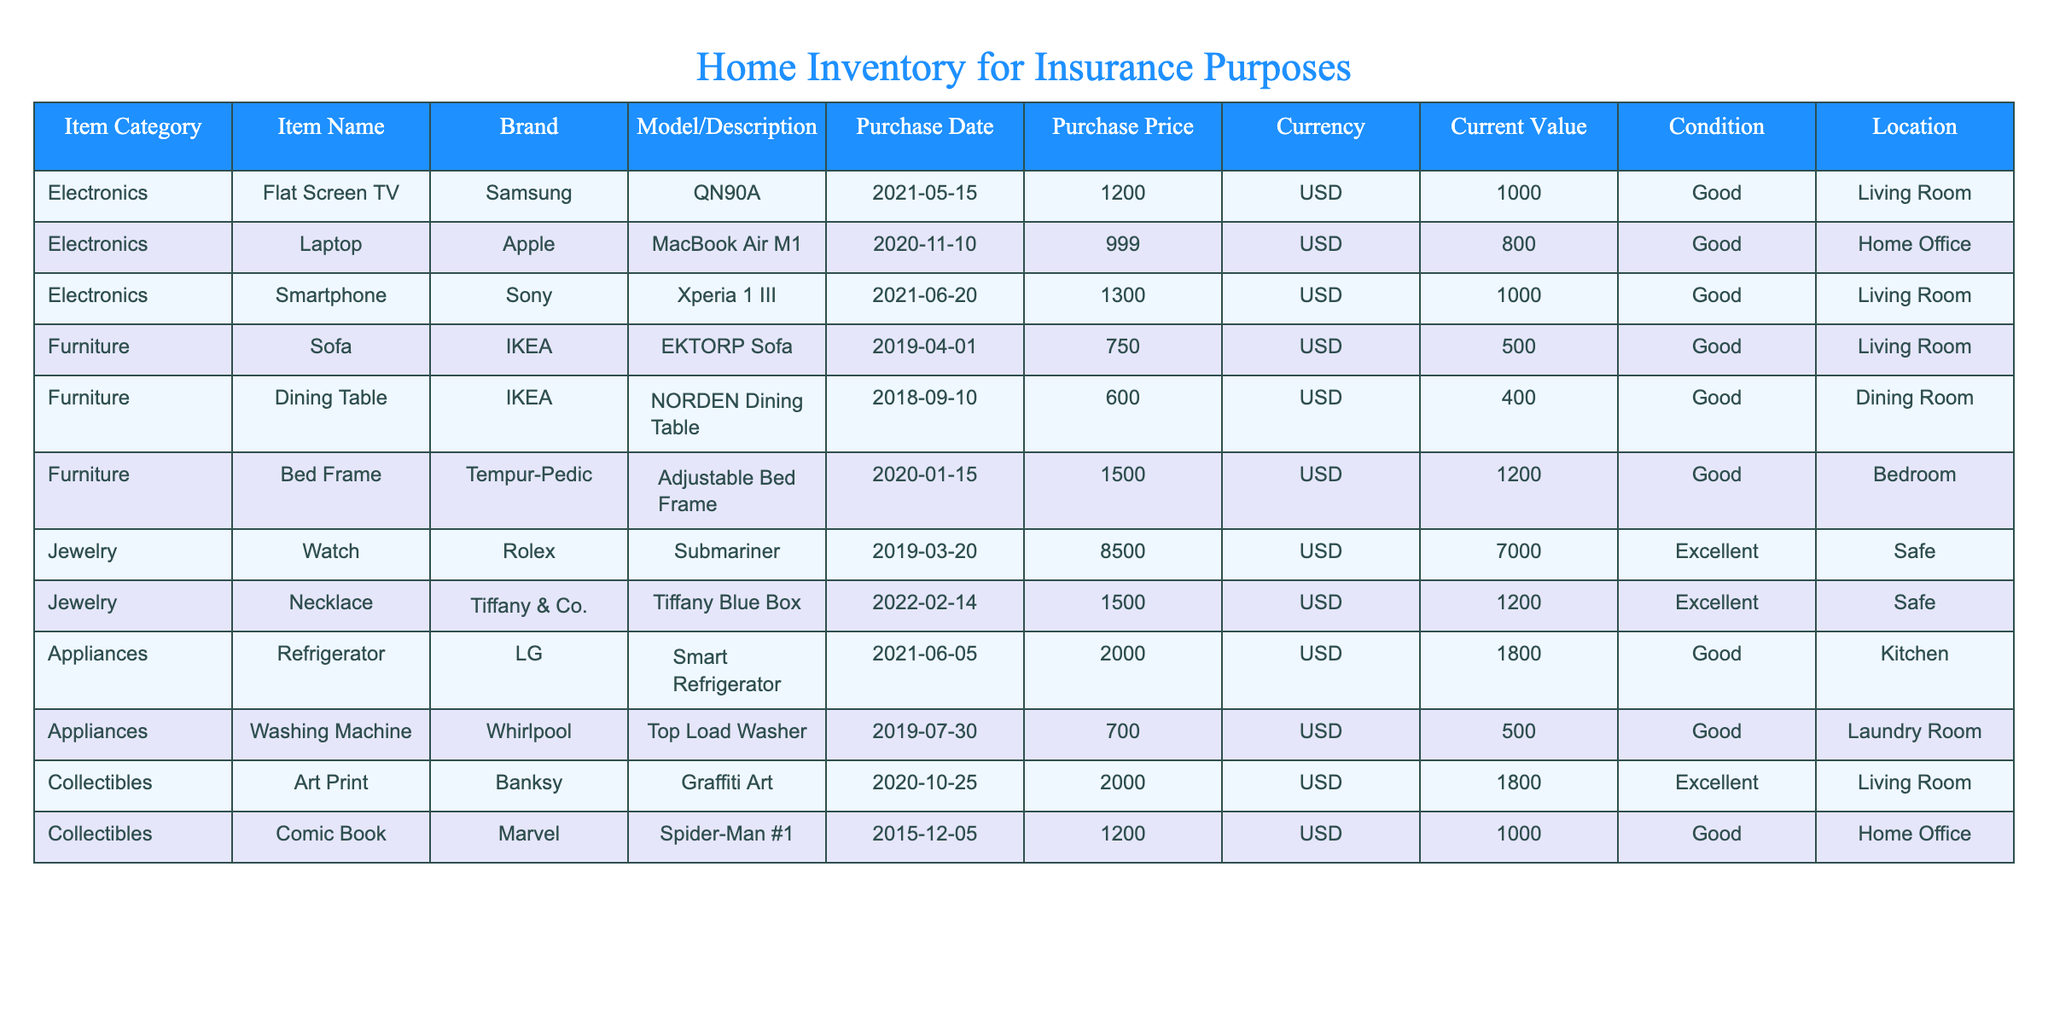What is the current value of the Flat Screen TV? The table lists the Flat Screen TV under the Electronics category and shows its current value. By checking the respective row, the current value is found to be 1000 USD.
Answer: 1000 USD What item has the highest purchase price? To find this, we compare the purchase prices of all items listed in the table. By scanning through the Purchase Price column, the highest value is identified as 8500 USD for the Rolex Watch.
Answer: 8500 USD How much is the total current value of all the items listed? We add the current values of all items: 1000 + 800 + 1000 + 500 + 400 + 1200 + 7000 + 1200 + 1800 + 500 + 1800 + 1000 = 19300 USD. Thus, the total current value is 19300 USD.
Answer: 19300 USD Is the Dining Table in good condition? By checking the condition of the Dining Table in the table, we see that its condition status is labeled as "Good". Therefore, it is indeed in good condition.
Answer: Yes Which category has the most expensive item, and what is that item's current value? We examine the current values in each category. The highest current value found is 7000 USD for the Rolex watch in the Jewelry category. Therefore, the category 'Jewelry' has the most expensive item.
Answer: Jewelry, 7000 USD What is the average purchase price of the appliances? The purchase prices listed for appliances are: 2000 (Refrigerator) and 700 (Washing Machine). To find the average, we sum these values (2000 + 700 = 2700) and divide by the number of appliances (2), resulting in an average of 1350 USD.
Answer: 1350 USD Is there any item in the Living Room? The Living Room is specified in the Location column, and the items listed there are the Flat Screen TV, Smartphone, and Art Print. Thus, we have items in the Living Room.
Answer: Yes How much more is the condition of the Jewelry worth compared to the Appliances? The total current value of Jewelry is 7000 (Watch) + 1200 (Necklace) = 8200 USD. The total current value of Appliances is 1800 (Refrigerator) + 500 (Washing Machine) = 2300 USD. To find out how much more Jewelry is worth, we subtract the total value of appliances from that of jewelry: 8200 - 2300 = 5900 USD; hence, Jewelry is worth 5900 USD more.
Answer: 5900 USD 